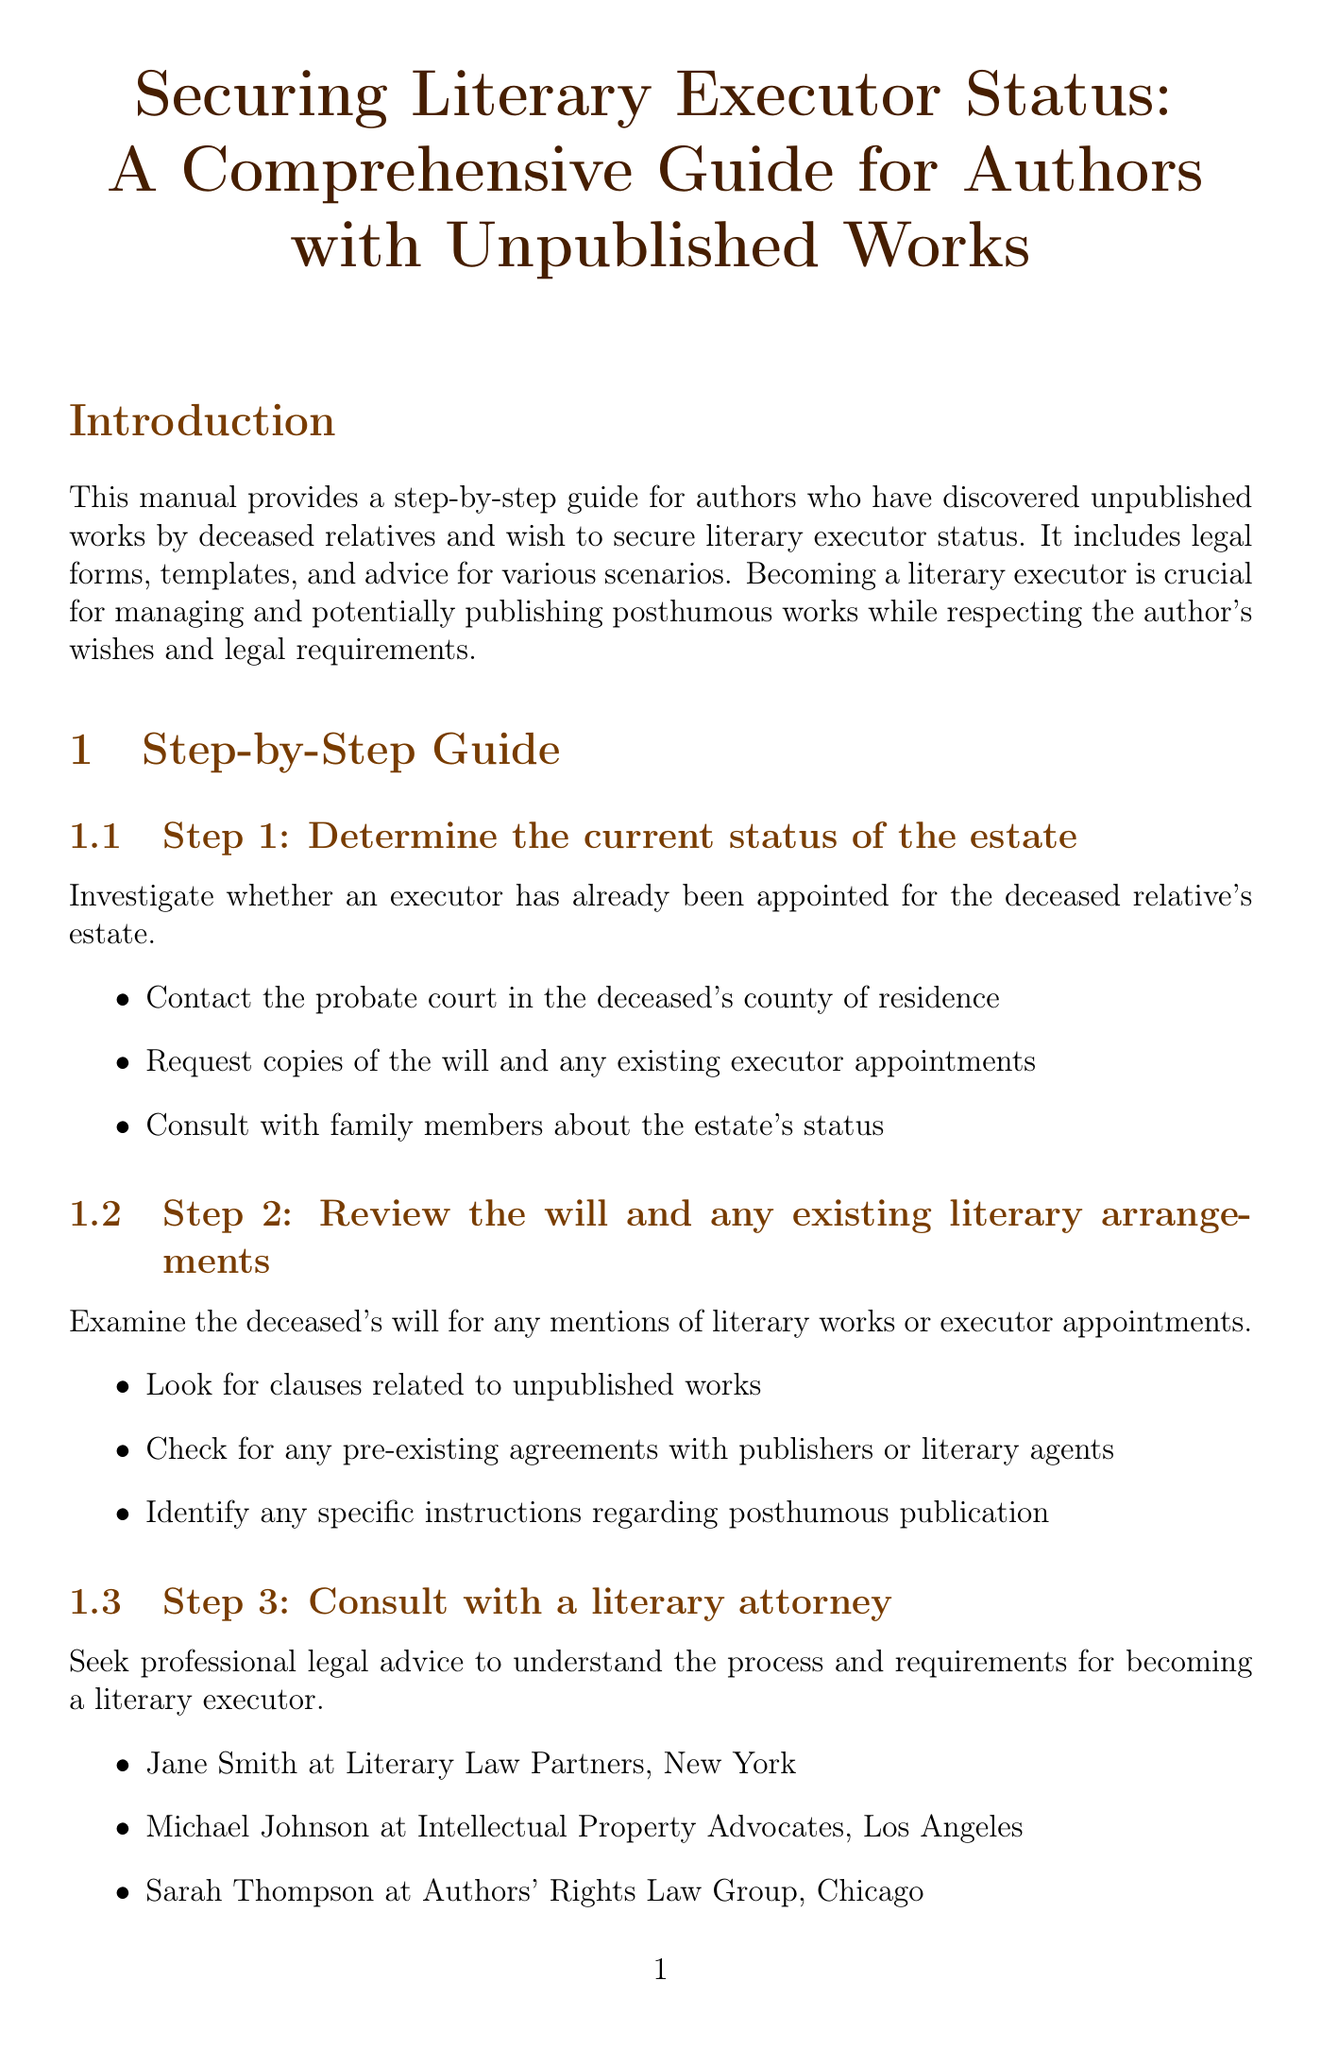What is the title of the manual? The title of the manual, as stated in the document, is "Securing Literary Executor Status: A Comprehensive Guide for Authors with Unpublished Works."
Answer: Securing Literary Executor Status: A Comprehensive Guide for Authors with Unpublished Works What is the first step to secure literary executor status? The first step outlined in the manual is to "Determine the current status of the estate."
Answer: Determine the current status of the estate What form is required for the petition to become a literary executor? The document lists "Petition for Probate (Form DE-111)" as one of the required forms for the petition.
Answer: Petition for Probate (Form DE-111) Who should be notified about the petition for literary executor status? The manual advises notifying several parties, including "Immediate family members" and "The Authors Guild."
Answer: Immediate family members How many recommended attorneys are listed? There are three attorneys recommended for consultation in the document.
Answer: Three What section includes templates for legal documents? The section titled "Legal Forms and Templates" contains templates for various legal documents.
Answer: Legal Forms and Templates What is one key component of the Literary Executor Appointment Agreement? The document states that one key component is "Identification of the author and the appointed executor."
Answer: Identification of the author and the appointed executor Which resource is focused on managing a deceased author's literary legacy? The resource titled "The Literary Executor's Handbook" by Elizabeth Maguire is focused on managing a deceased author's literary legacy.
Answer: The Literary Executor's Handbook What is the purpose of becoming a literary executor? According to the introduction, the purpose is to manage and potentially publish posthumous works while respecting the author's wishes and legal requirements.
Answer: Manage and potentially publish posthumous works while respecting the author's wishes and legal requirements 